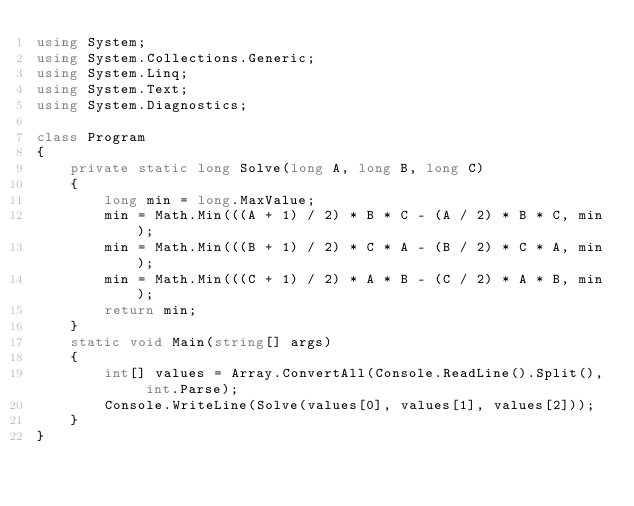Convert code to text. <code><loc_0><loc_0><loc_500><loc_500><_C#_>using System;
using System.Collections.Generic;
using System.Linq;
using System.Text;
using System.Diagnostics;

class Program
{
    private static long Solve(long A, long B, long C)
    {
        long min = long.MaxValue;
        min = Math.Min(((A + 1) / 2) * B * C - (A / 2) * B * C, min);
        min = Math.Min(((B + 1) / 2) * C * A - (B / 2) * C * A, min);
        min = Math.Min(((C + 1) / 2) * A * B - (C / 2) * A * B, min);
        return min;
    }
    static void Main(string[] args)
    {
        int[] values = Array.ConvertAll(Console.ReadLine().Split(), int.Parse);
        Console.WriteLine(Solve(values[0], values[1], values[2]));
    }
}
</code> 